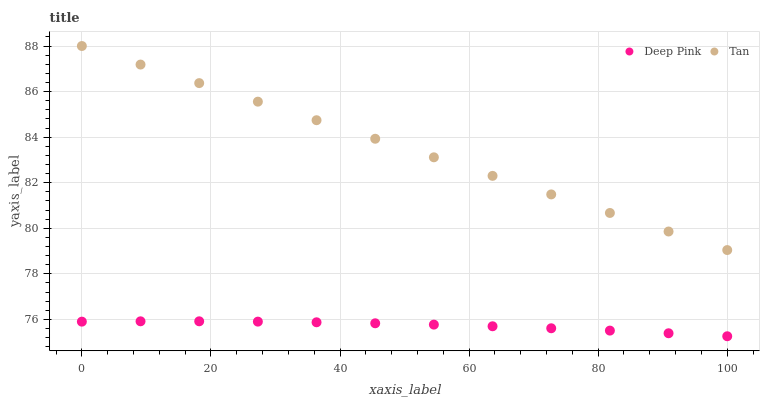Does Deep Pink have the minimum area under the curve?
Answer yes or no. Yes. Does Tan have the maximum area under the curve?
Answer yes or no. Yes. Does Deep Pink have the maximum area under the curve?
Answer yes or no. No. Is Tan the smoothest?
Answer yes or no. Yes. Is Deep Pink the roughest?
Answer yes or no. Yes. Is Deep Pink the smoothest?
Answer yes or no. No. Does Deep Pink have the lowest value?
Answer yes or no. Yes. Does Tan have the highest value?
Answer yes or no. Yes. Does Deep Pink have the highest value?
Answer yes or no. No. Is Deep Pink less than Tan?
Answer yes or no. Yes. Is Tan greater than Deep Pink?
Answer yes or no. Yes. Does Deep Pink intersect Tan?
Answer yes or no. No. 